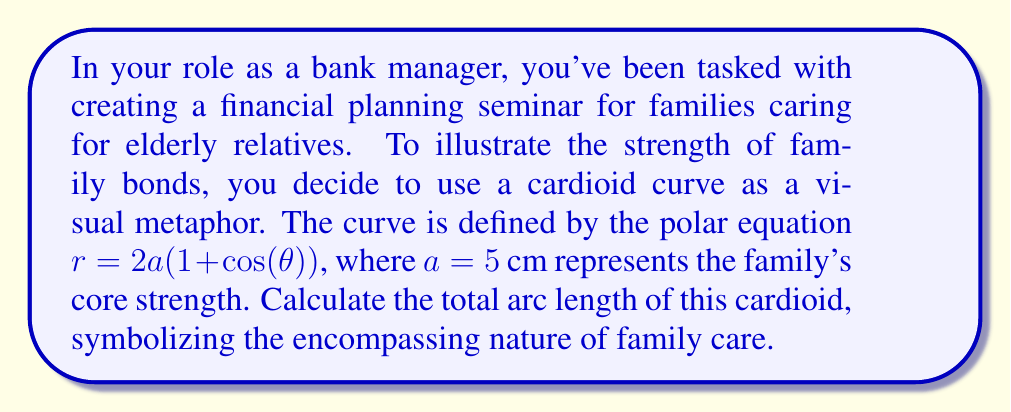Teach me how to tackle this problem. To calculate the arc length of a polar curve, we use the formula:

$$L = \int_{0}^{2\pi} \sqrt{r^2 + \left(\frac{dr}{d\theta}\right)^2} d\theta$$

For the given cardioid $r = 2a(1 + \cos(\theta))$ with $a = 5$ cm:

1) First, we need to find $\frac{dr}{d\theta}$:
   $$\frac{dr}{d\theta} = -2a\sin(\theta)$$

2) Now, let's substitute these into the arc length formula:
   $$L = \int_{0}^{2\pi} \sqrt{(2a(1 + \cos(\theta)))^2 + (-2a\sin(\theta))^2} d\theta$$

3) Simplify inside the square root:
   $$L = \int_{0}^{2\pi} \sqrt{4a^2(1 + 2\cos(\theta) + \cos^2(\theta) + \sin^2(\theta))} d\theta$$

4) Recall that $\sin^2(\theta) + \cos^2(\theta) = 1$:
   $$L = \int_{0}^{2\pi} \sqrt{4a^2(2 + 2\cos(\theta))} d\theta$$

5) Factor out $4a^2$:
   $$L = 2a\int_{0}^{2\pi} \sqrt{2 + 2\cos(\theta)} d\theta$$

6) Use the half-angle formula: $\cos(\theta) = 1 - 2\sin^2(\frac{\theta}{2})$
   $$L = 2a\int_{0}^{2\pi} \sqrt{4 - 4\sin^2(\frac{\theta}{2})} d\theta$$

7) Simplify:
   $$L = 4a\int_{0}^{2\pi} \sqrt{1 - \sin^2(\frac{\theta}{2})} d\theta = 4a\int_{0}^{2\pi} \cos(\frac{\theta}{2}) d\theta$$

8) Evaluate the integral:
   $$L = 4a[2\sin(\frac{\theta}{2})]_{0}^{2\pi} = 16a$$

9) Substitute $a = 5$ cm:
   $$L = 16 * 5 = 80\text{ cm}$$
Answer: $80$ cm 